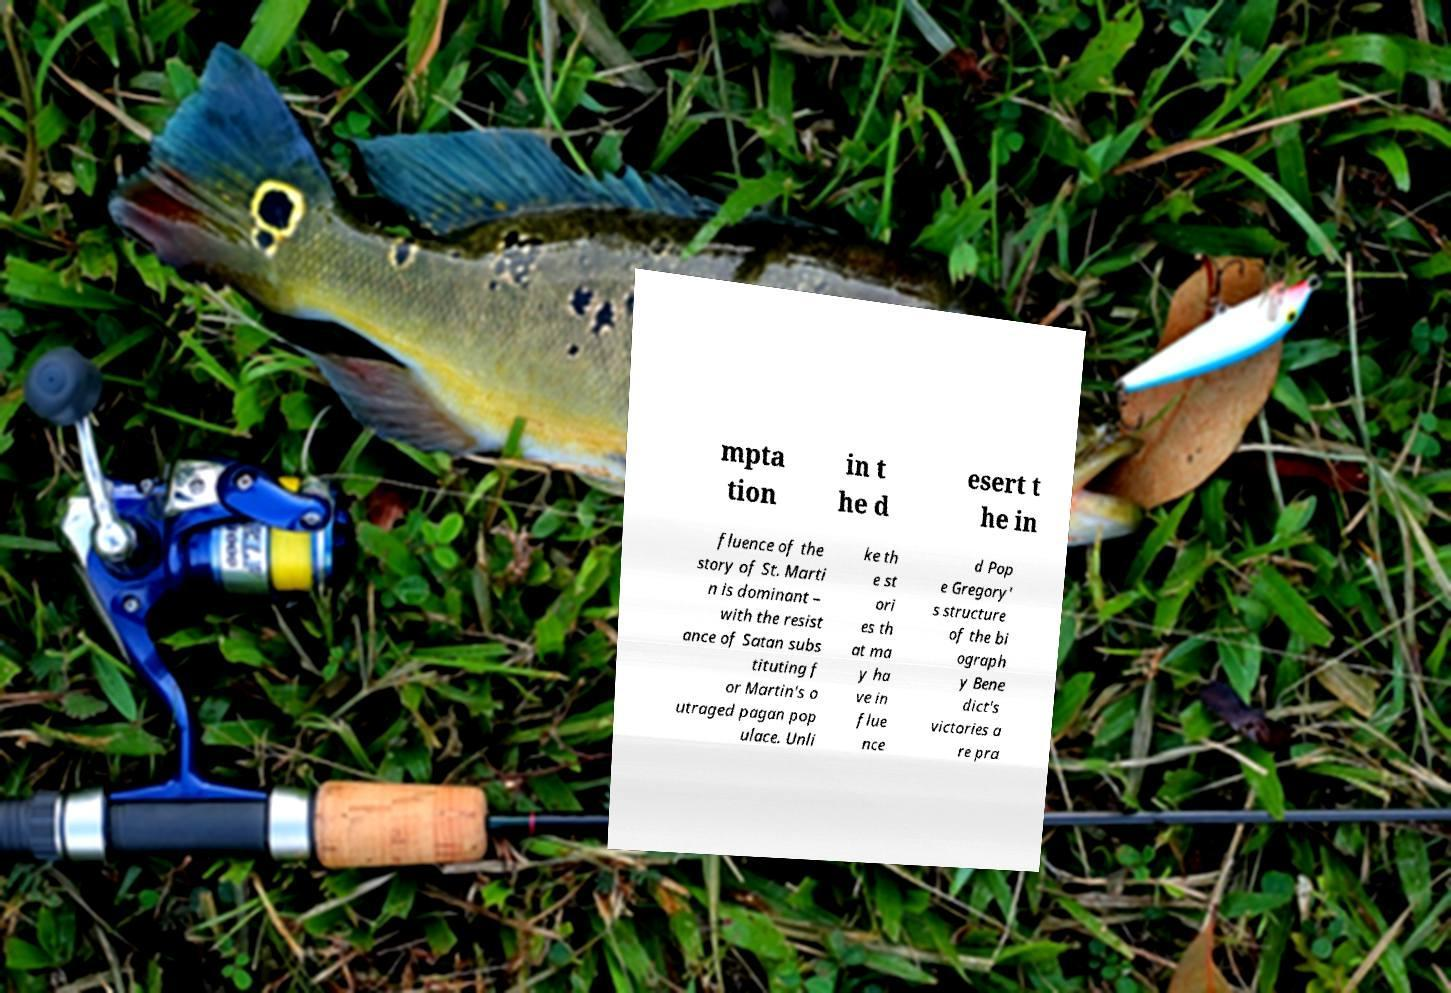Can you accurately transcribe the text from the provided image for me? mpta tion in t he d esert t he in fluence of the story of St. Marti n is dominant – with the resist ance of Satan subs tituting f or Martin's o utraged pagan pop ulace. Unli ke th e st ori es th at ma y ha ve in flue nce d Pop e Gregory' s structure of the bi ograph y Bene dict's victories a re pra 